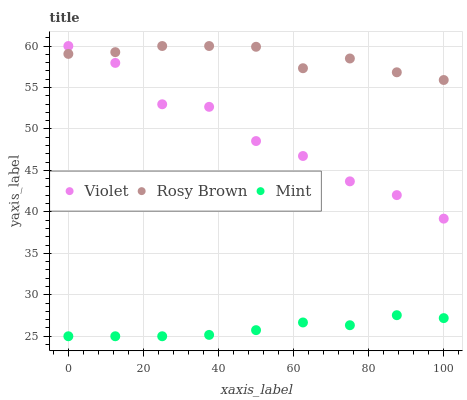Does Mint have the minimum area under the curve?
Answer yes or no. Yes. Does Rosy Brown have the maximum area under the curve?
Answer yes or no. Yes. Does Violet have the minimum area under the curve?
Answer yes or no. No. Does Violet have the maximum area under the curve?
Answer yes or no. No. Is Mint the smoothest?
Answer yes or no. Yes. Is Violet the roughest?
Answer yes or no. Yes. Is Violet the smoothest?
Answer yes or no. No. Is Mint the roughest?
Answer yes or no. No. Does Mint have the lowest value?
Answer yes or no. Yes. Does Violet have the lowest value?
Answer yes or no. No. Does Violet have the highest value?
Answer yes or no. Yes. Does Mint have the highest value?
Answer yes or no. No. Is Mint less than Violet?
Answer yes or no. Yes. Is Violet greater than Mint?
Answer yes or no. Yes. Does Violet intersect Rosy Brown?
Answer yes or no. Yes. Is Violet less than Rosy Brown?
Answer yes or no. No. Is Violet greater than Rosy Brown?
Answer yes or no. No. Does Mint intersect Violet?
Answer yes or no. No. 